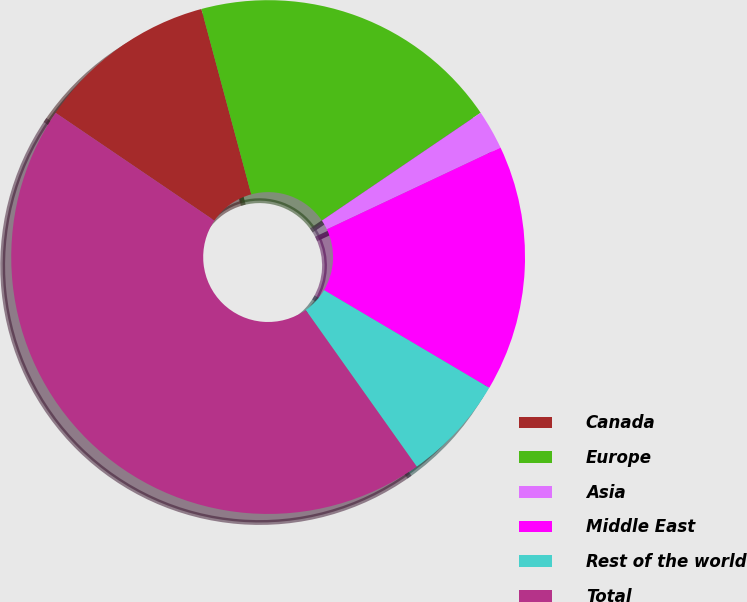Convert chart. <chart><loc_0><loc_0><loc_500><loc_500><pie_chart><fcel>Canada<fcel>Europe<fcel>Asia<fcel>Middle East<fcel>Rest of the world<fcel>Total<nl><fcel>11.33%<fcel>19.69%<fcel>2.49%<fcel>15.51%<fcel>6.68%<fcel>44.31%<nl></chart> 